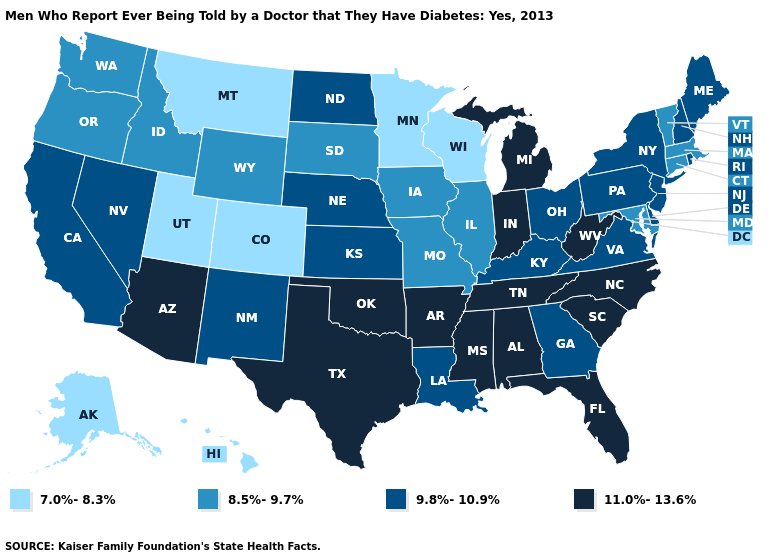Name the states that have a value in the range 7.0%-8.3%?
Give a very brief answer. Alaska, Colorado, Hawaii, Minnesota, Montana, Utah, Wisconsin. Name the states that have a value in the range 7.0%-8.3%?
Answer briefly. Alaska, Colorado, Hawaii, Minnesota, Montana, Utah, Wisconsin. Name the states that have a value in the range 8.5%-9.7%?
Write a very short answer. Connecticut, Idaho, Illinois, Iowa, Maryland, Massachusetts, Missouri, Oregon, South Dakota, Vermont, Washington, Wyoming. What is the value of Maryland?
Short answer required. 8.5%-9.7%. What is the lowest value in states that border New Jersey?
Keep it brief. 9.8%-10.9%. What is the lowest value in the USA?
Keep it brief. 7.0%-8.3%. Among the states that border Pennsylvania , which have the highest value?
Give a very brief answer. West Virginia. Does Georgia have the highest value in the South?
Write a very short answer. No. What is the value of Illinois?
Write a very short answer. 8.5%-9.7%. What is the value of Arizona?
Be succinct. 11.0%-13.6%. Does the first symbol in the legend represent the smallest category?
Give a very brief answer. Yes. Does Virginia have the highest value in the South?
Write a very short answer. No. What is the highest value in the USA?
Give a very brief answer. 11.0%-13.6%. Does Texas have the highest value in the USA?
Write a very short answer. Yes. Does Wisconsin have the lowest value in the USA?
Keep it brief. Yes. 